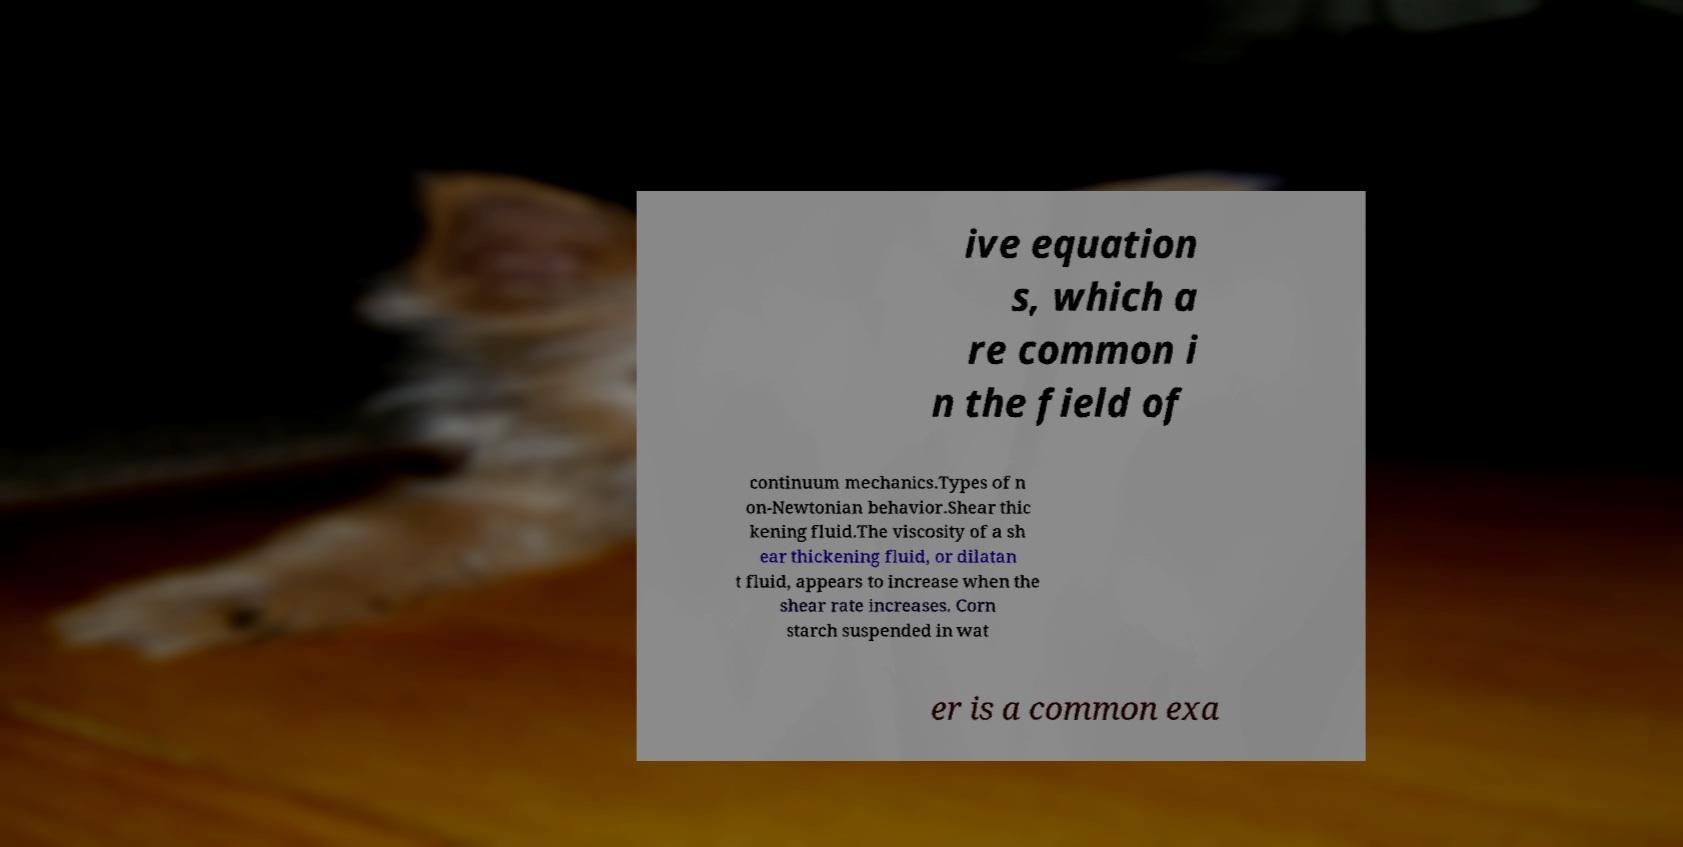Please identify and transcribe the text found in this image. ive equation s, which a re common i n the field of continuum mechanics.Types of n on-Newtonian behavior.Shear thic kening fluid.The viscosity of a sh ear thickening fluid, or dilatan t fluid, appears to increase when the shear rate increases. Corn starch suspended in wat er is a common exa 